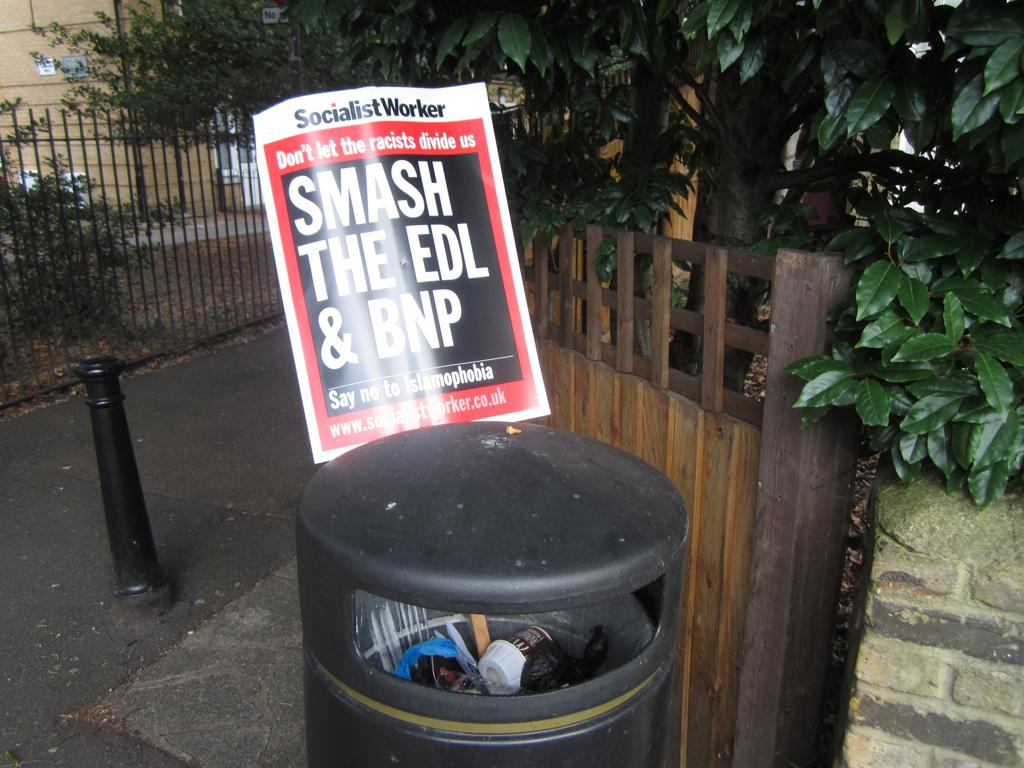Provide a one-sentence caption for the provided image. A sign sticking out of a trash bin that says SMASH THE EDL & BNP. 